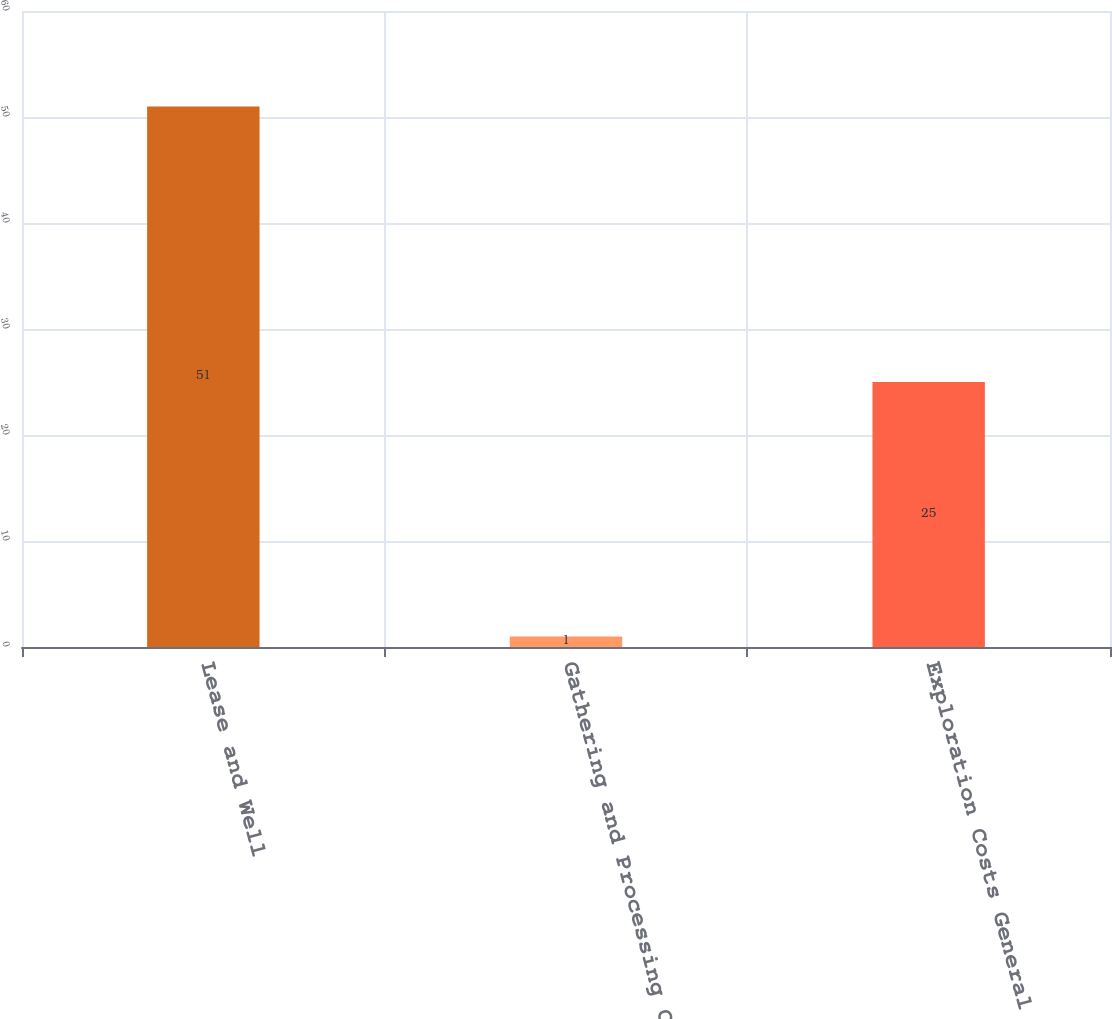Convert chart to OTSL. <chart><loc_0><loc_0><loc_500><loc_500><bar_chart><fcel>Lease and Well<fcel>Gathering and Processing Costs<fcel>Exploration Costs General and<nl><fcel>51<fcel>1<fcel>25<nl></chart> 